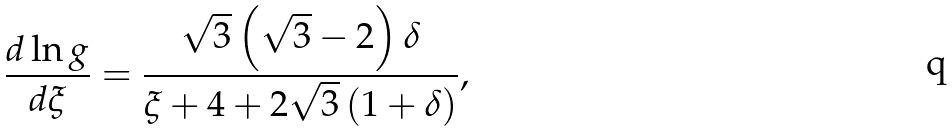Convert formula to latex. <formula><loc_0><loc_0><loc_500><loc_500>\frac { d \ln g } { d \xi } = \frac { \sqrt { 3 } \left ( \sqrt { 3 } - 2 \right ) \delta } { \xi + 4 + 2 \sqrt { 3 } \left ( 1 + \delta \right ) } ,</formula> 